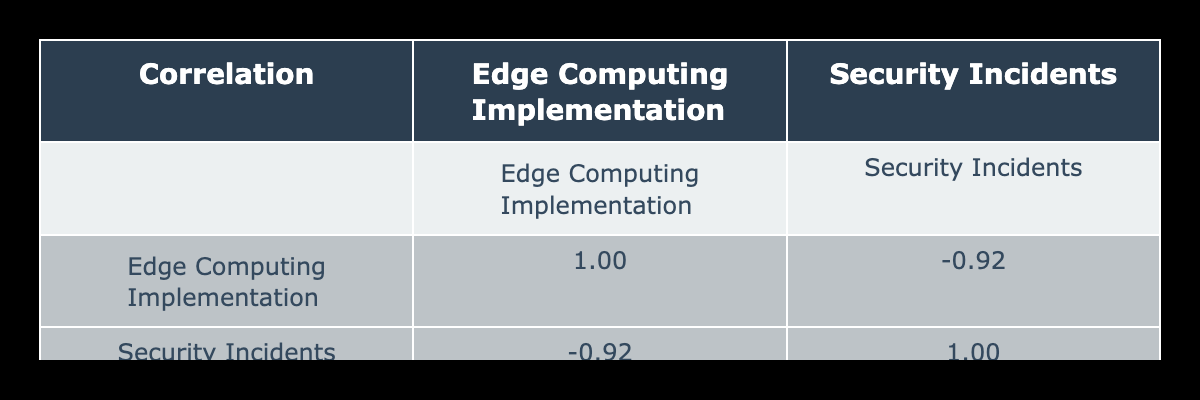What is the correlation value between Edge Computing Implementation and Number of Security Incidents? From the table, the correlation value calculated between Edge Computing Implementation Level and Number of Security Incidents is provided directly in the cells, appearing as a number in the corresponding box.
Answer: The correlation value is -0.77 What level of Edge Computing implementation does the company with the most security incidents have? By looking at the row for CloudSolutions, which has the highest number of security incidents (35), we notice that it has an Edge Computing Implementation Level of 2.
Answer: The level is 2 How many security incidents does TechCorp experience per level of Edge Computing implementation? TechCorp has an Edge Computing implementation level of 8. It has 12 security incidents in the last year. To find the number of incidents per level, we divide 12 incidents by 8 levels resulting in 1.5 incidents per level of Edge Computing implementation.
Answer: The incidents per level are 1.5 Which enterprise has the lowest number of security incidents and what is its Edge Computing implementation level? MediaConnect experienced the lowest number of security incidents, which is 5. Looking at the table, we see that MediaConnect has an Edge Computing implementation level of 9.
Answer: The enterprise is MediaConnect with level 9 How does HealthNet’s number of security incidents compare to the average number of incidents for all enterprises with an Edge Computing level greater than 5? First, we find the entities greater than level 5, which are TechCorp, HealthNet, and MediaConnect. Their incidents are 12, 8, and 5 respectively, giving us an average of (12 + 8 + 5) / 3 = 8.33. Comparing this to HealthNet’s 8 incidents, it is slightly below average.
Answer: HealthNet's incidents are below average Do enterprises with higher Edge Computing Implementation levels generally have fewer security incidents? We can analyze the correlation value of -0.77 from the table, indicating a strong negative correlation. This suggests that as the Edge Computing implementation increases, the number of security incidents tends to decrease.
Answer: Yes, generally they have fewer incidents 